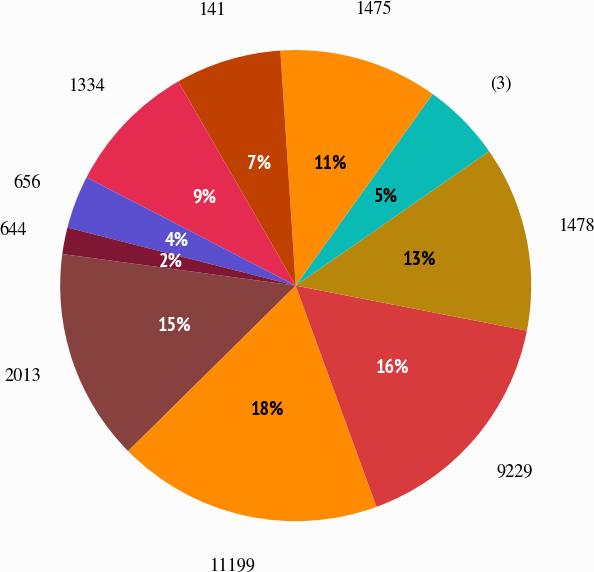Convert chart to OTSL. <chart><loc_0><loc_0><loc_500><loc_500><pie_chart><fcel>2013<fcel>11199<fcel>9229<fcel>1478<fcel>(3)<fcel>1475<fcel>141<fcel>1334<fcel>656<fcel>644<nl><fcel>14.54%<fcel>18.18%<fcel>16.36%<fcel>12.73%<fcel>5.46%<fcel>10.91%<fcel>7.27%<fcel>9.09%<fcel>3.64%<fcel>1.82%<nl></chart> 